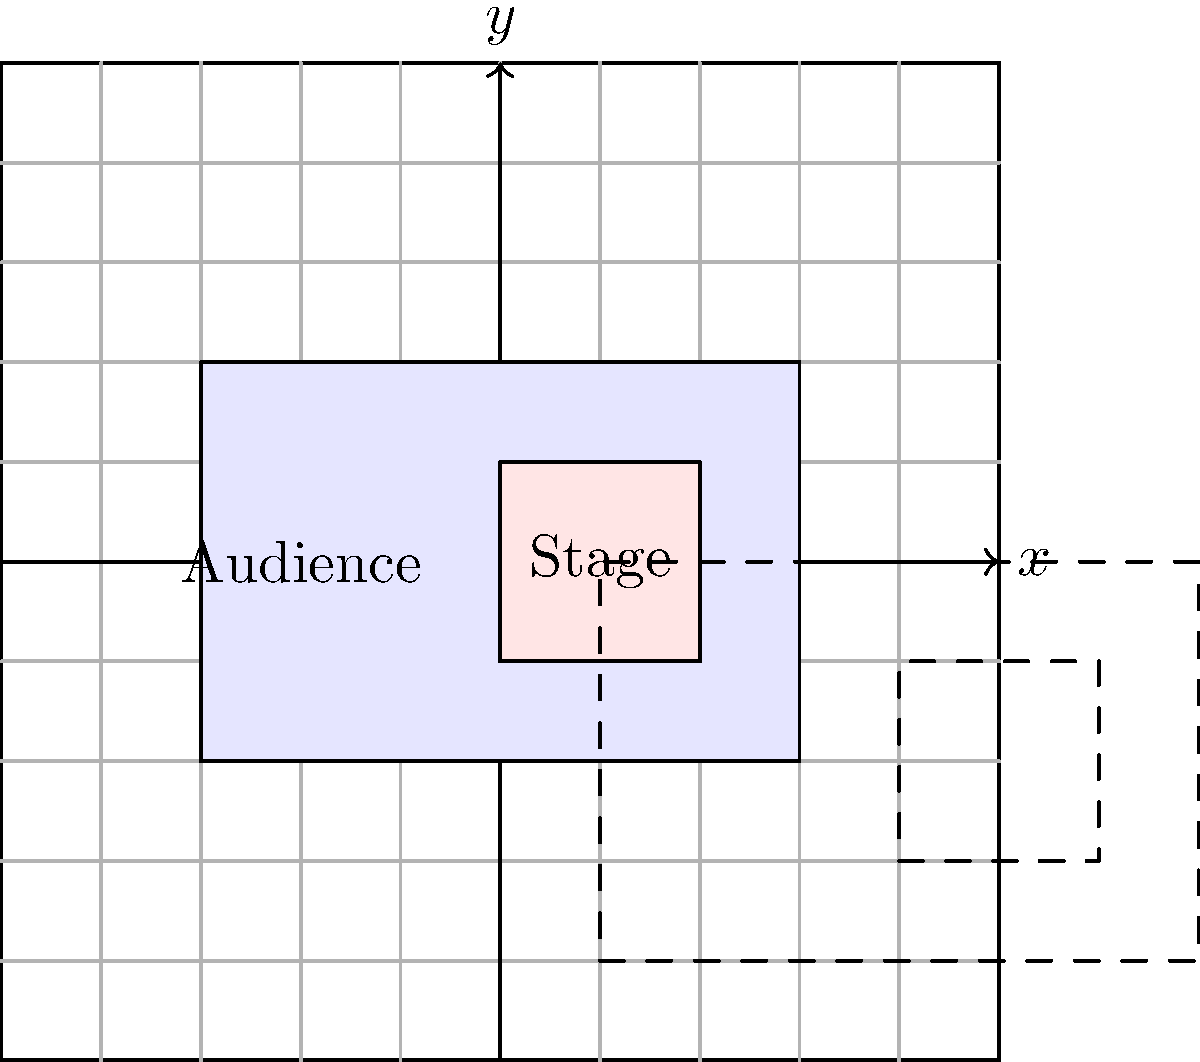In the coordinate plane above, a simplified eSports arena layout is shown. The rectangular arena has dimensions of 6 units by 4 units, with a stage area of 2 units by 2 units on the right side. If this entire layout is translated 4 units to the right and 2 units down, what will be the coordinates of the top-left corner of the translated stage area? To solve this problem, let's follow these steps:

1. Identify the original coordinates of the top-left corner of the stage:
   - The arena is centered at (0,0) with dimensions 6x4
   - The stage is on the right side, 2x2
   - So, the top-left corner of the stage is at (0,1)

2. Understand the translation:
   - The entire layout is moved 4 units right (positive x-direction)
   - It's also moved 2 units down (negative y-direction)

3. Apply the translation:
   - To translate a point $(x,y)$ by $(a,b)$, we add the corresponding coordinates:
     $(x+a, y+b)$
   - In this case, we're translating (0,1) by (4,-2)
   - So, the new coordinates will be:
     $(0+4, 1+(-2)) = (4, -1)$

Therefore, after the translation, the top-left corner of the stage will be at the coordinate (4,-1).
Answer: $(4,-1)$ 